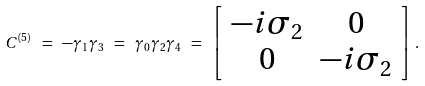Convert formula to latex. <formula><loc_0><loc_0><loc_500><loc_500>C ^ { ( 5 ) } \ = \ - \gamma _ { 1 } \gamma _ { 3 } \ = \ \gamma _ { 0 } \gamma _ { 2 } \gamma _ { 4 } \ = \ \left [ \begin{array} { c c } { { - i \sigma _ { 2 } } } & { 0 } \\ { 0 } & { { - i \sigma _ { 2 } } } \end{array} \right ] \, .</formula> 